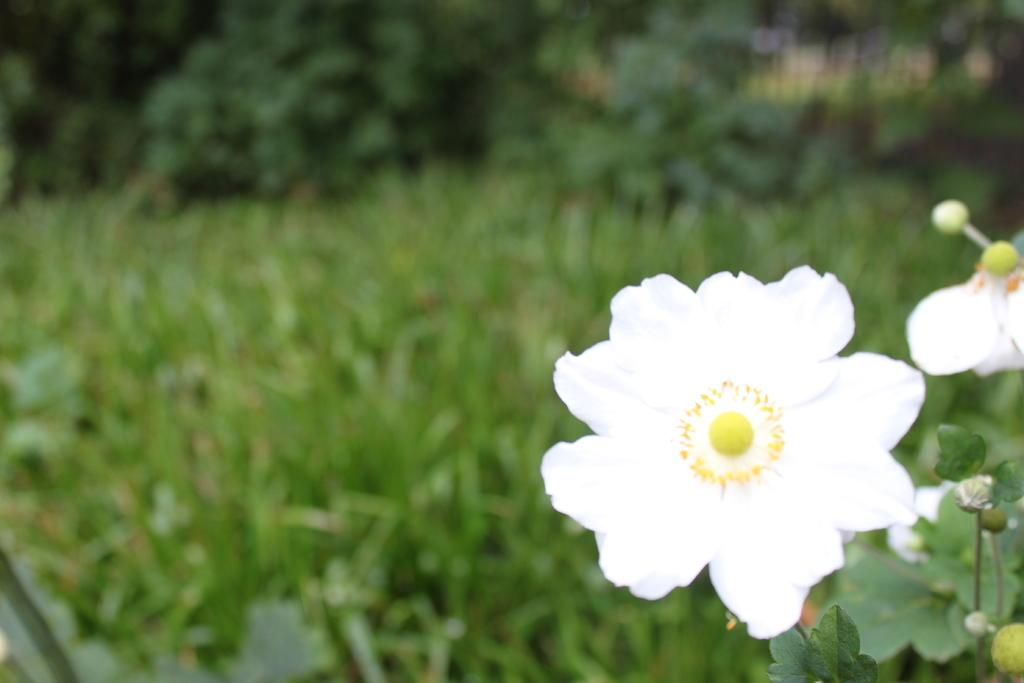What type of flower is in the image? There is a white flower in the image. What is covering the ground in the image? The ground is covered with plants. Can you describe the background of the image? The background of the image is slightly blurry. How many stitches are visible on the flower in the image? There are no stitches visible on the flower in the image, as it is a real flower and not a fabric or sewn object. 